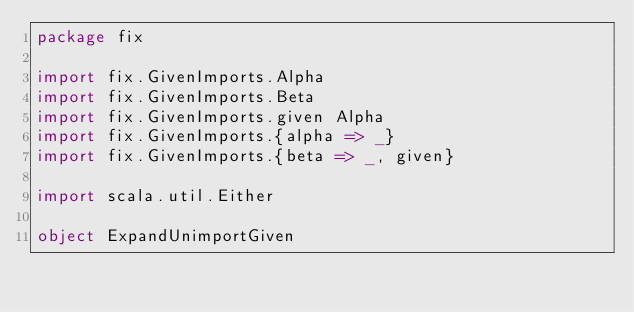<code> <loc_0><loc_0><loc_500><loc_500><_Scala_>package fix

import fix.GivenImports.Alpha
import fix.GivenImports.Beta
import fix.GivenImports.given Alpha
import fix.GivenImports.{alpha => _}
import fix.GivenImports.{beta => _, given}

import scala.util.Either

object ExpandUnimportGiven
</code> 